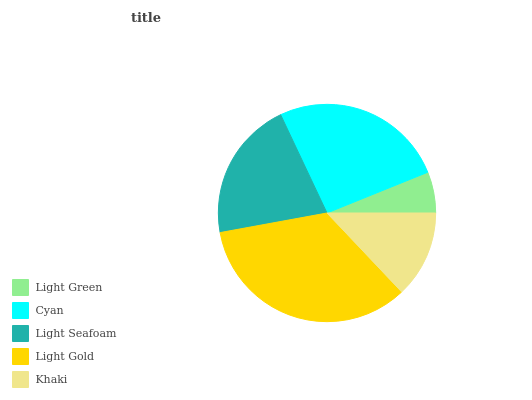Is Light Green the minimum?
Answer yes or no. Yes. Is Light Gold the maximum?
Answer yes or no. Yes. Is Cyan the minimum?
Answer yes or no. No. Is Cyan the maximum?
Answer yes or no. No. Is Cyan greater than Light Green?
Answer yes or no. Yes. Is Light Green less than Cyan?
Answer yes or no. Yes. Is Light Green greater than Cyan?
Answer yes or no. No. Is Cyan less than Light Green?
Answer yes or no. No. Is Light Seafoam the high median?
Answer yes or no. Yes. Is Light Seafoam the low median?
Answer yes or no. Yes. Is Khaki the high median?
Answer yes or no. No. Is Khaki the low median?
Answer yes or no. No. 